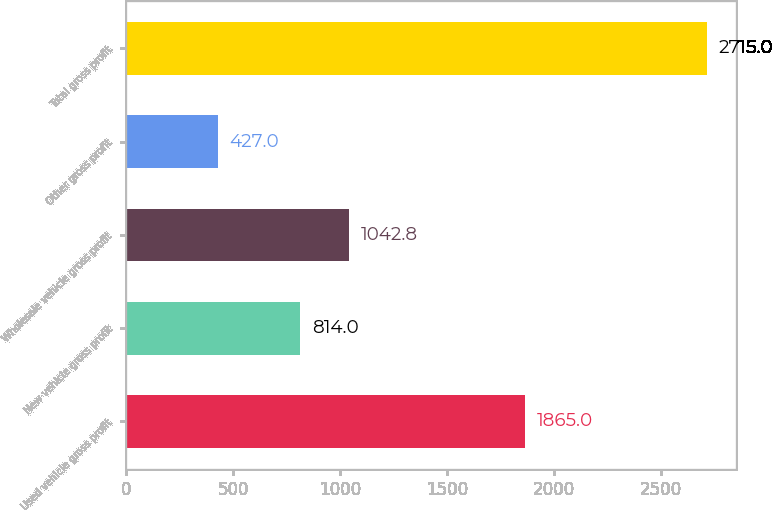Convert chart to OTSL. <chart><loc_0><loc_0><loc_500><loc_500><bar_chart><fcel>Used vehicle gross profit<fcel>New vehicle gross profit<fcel>Wholesale vehicle gross profit<fcel>Other gross profit<fcel>Total gross profit<nl><fcel>1865<fcel>814<fcel>1042.8<fcel>427<fcel>2715<nl></chart> 